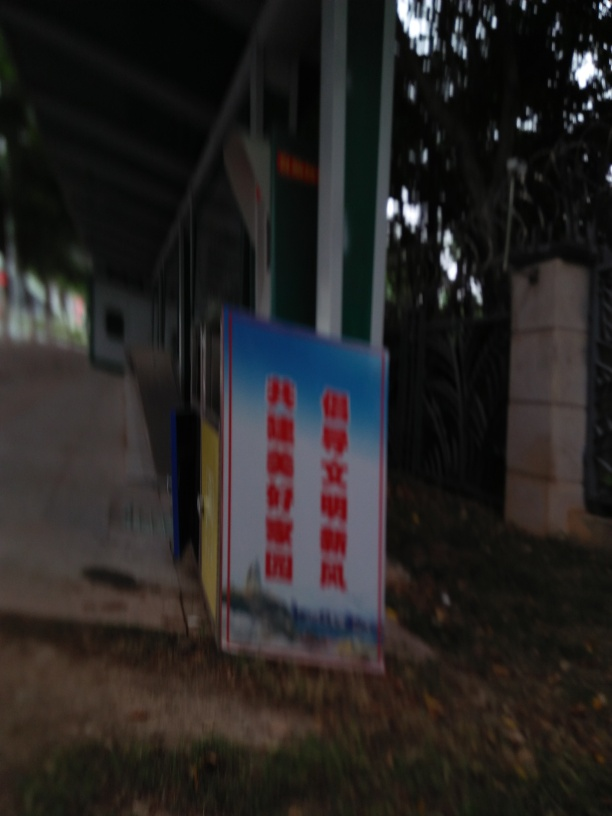What issues does this image have? The image is blurry, has focusing issues, and contains noise, making it difficult to discern the details. The overall lighting is dark, and any text present in the image is hard to read. The quality of the photograph would benefit from better lighting, proper focusing, and stabilization to reduce blur and noise. 